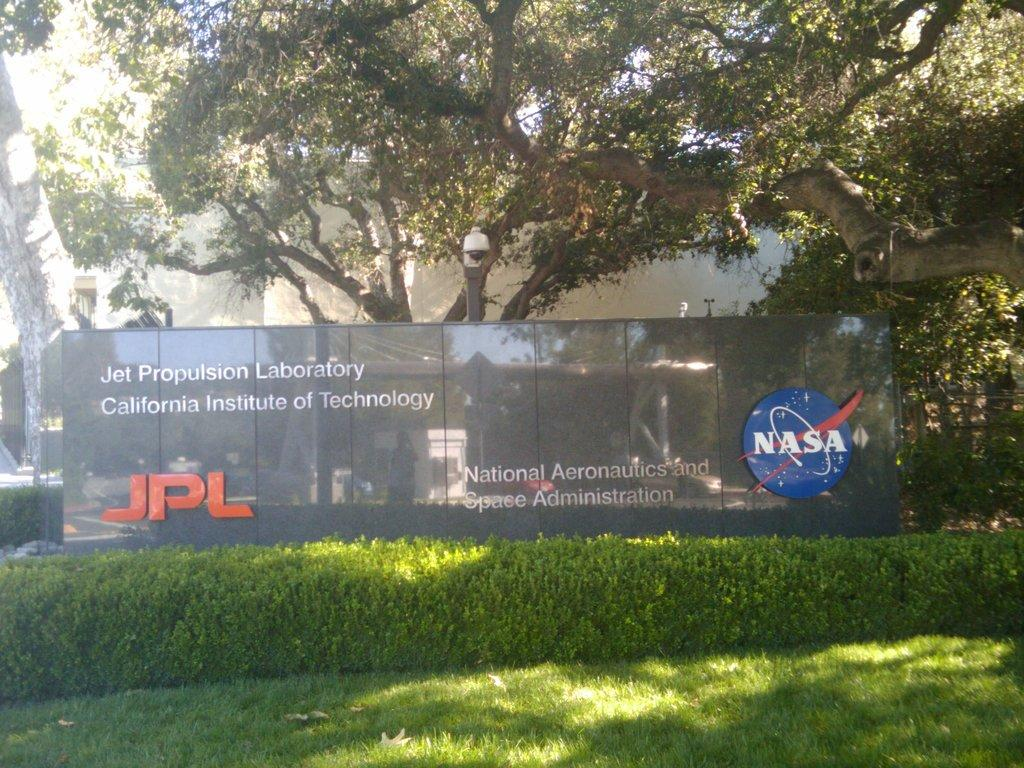What type of vegetation is at the bottom of the image? There is grass at the bottom of the image. What structures can be seen in the background of the image? There is a building in the background of the image. What type of natural elements are present in the background of the image? There are trees in the background of the image. What type of creature is crawling on the grass in the image? There is no creature visible on the grass in the image. What is the rate of growth for the trees in the background of the image? The rate of growth for the trees cannot be determined from the image alone. 